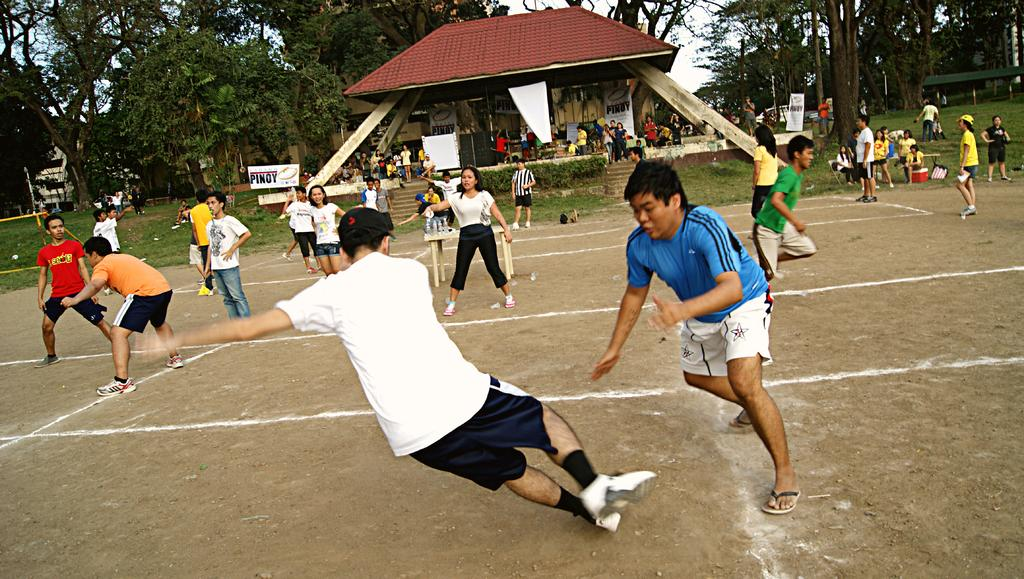What are the people in the foreground of the image doing? The people in the foreground of the image are playing in the ground. What can be seen in the background of the image? Trees and a stage are present in the background of the image. Are there any other people visible in the image? Yes, there are people in the background of the image. How many eggs are being bitten by the people in the image? There are no eggs present in the image, so it is not possible to determine how many are being bitten. 